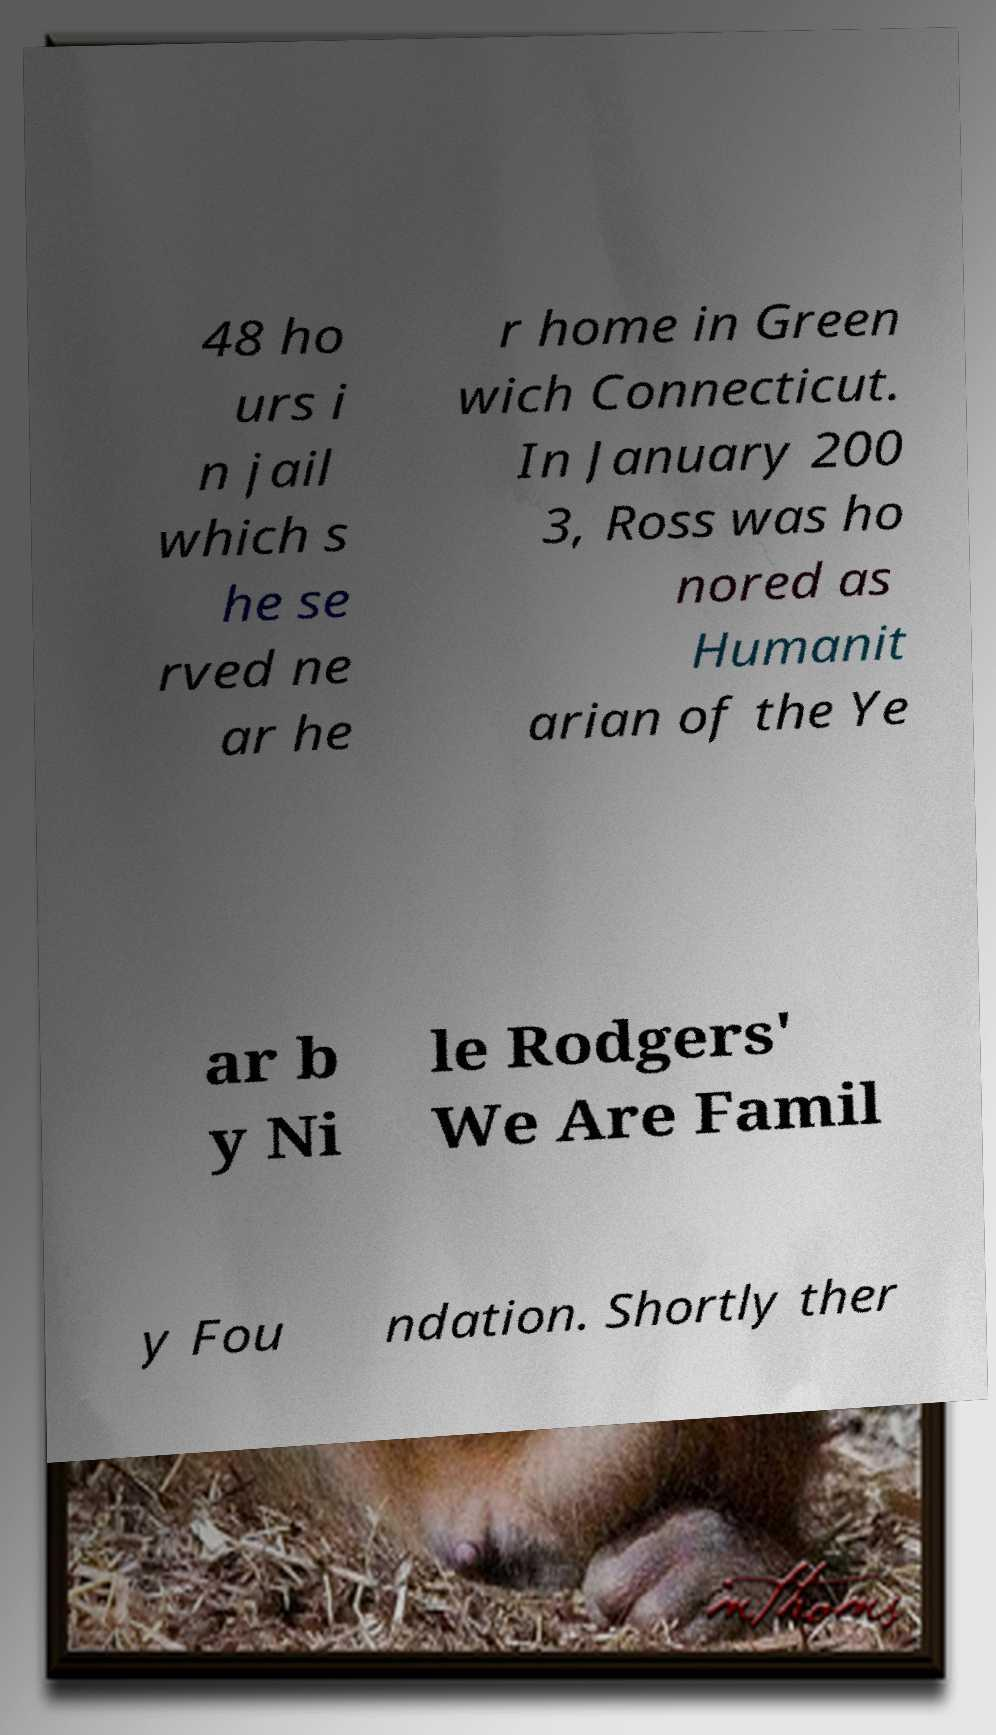There's text embedded in this image that I need extracted. Can you transcribe it verbatim? 48 ho urs i n jail which s he se rved ne ar he r home in Green wich Connecticut. In January 200 3, Ross was ho nored as Humanit arian of the Ye ar b y Ni le Rodgers' We Are Famil y Fou ndation. Shortly ther 